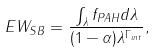<formula> <loc_0><loc_0><loc_500><loc_500>E W _ { S B } = \frac { \int _ { \lambda } f _ { P A H } d \lambda } { ( 1 - \alpha ) \lambda ^ { \Gamma _ { i n t } } } ,</formula> 